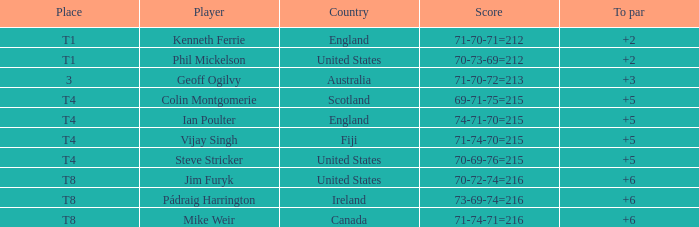With the scores of 70, 73, and 69, who had a total of 212? Phil Mickelson. 